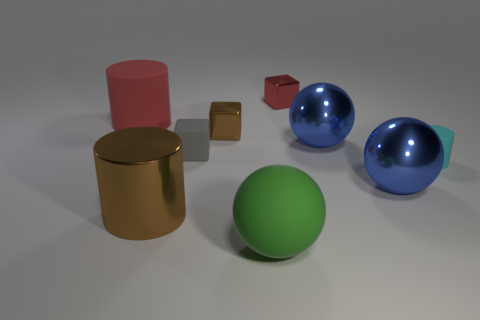What might be the relative sizes of these objects? Based on their appearance in the image, the sphere in the foreground seems to be larger than the tiny cube but smaller than the big blue sphere. The translucent cube is comparable in size to the green sphere, and the big cylinder seems to be the largest object in terms of height. Could these objects be part of a specific setting or used for a purpose? While we can't determine a specific use or setting with certainty, these objects could represent a variety of environments. They could be part of an artistic installation, a 3D rendering showcase, or perhaps teaching materials for a lesson on geometry and light in photography. Their simplicity and diversity in shape and texture lend them to a multitude of creative interpretations. 